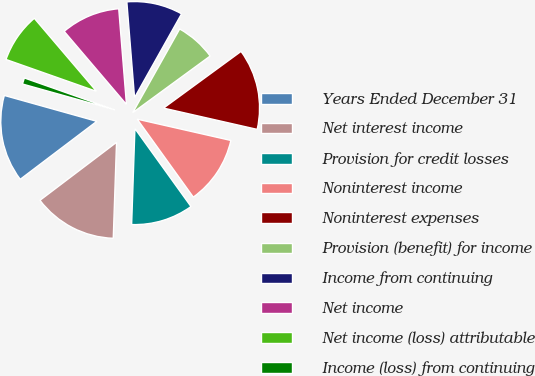<chart> <loc_0><loc_0><loc_500><loc_500><pie_chart><fcel>Years Ended December 31<fcel>Net interest income<fcel>Provision for credit losses<fcel>Noninterest income<fcel>Noninterest expenses<fcel>Provision (benefit) for income<fcel>Income from continuing<fcel>Net income<fcel>Net income (loss) attributable<fcel>Income (loss) from continuing<nl><fcel>14.66%<fcel>14.14%<fcel>10.47%<fcel>11.52%<fcel>13.61%<fcel>6.81%<fcel>9.42%<fcel>9.95%<fcel>8.38%<fcel>1.05%<nl></chart> 